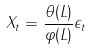<formula> <loc_0><loc_0><loc_500><loc_500>X _ { t } = \frac { \theta ( L ) } { \varphi ( L ) } \epsilon _ { t }</formula> 